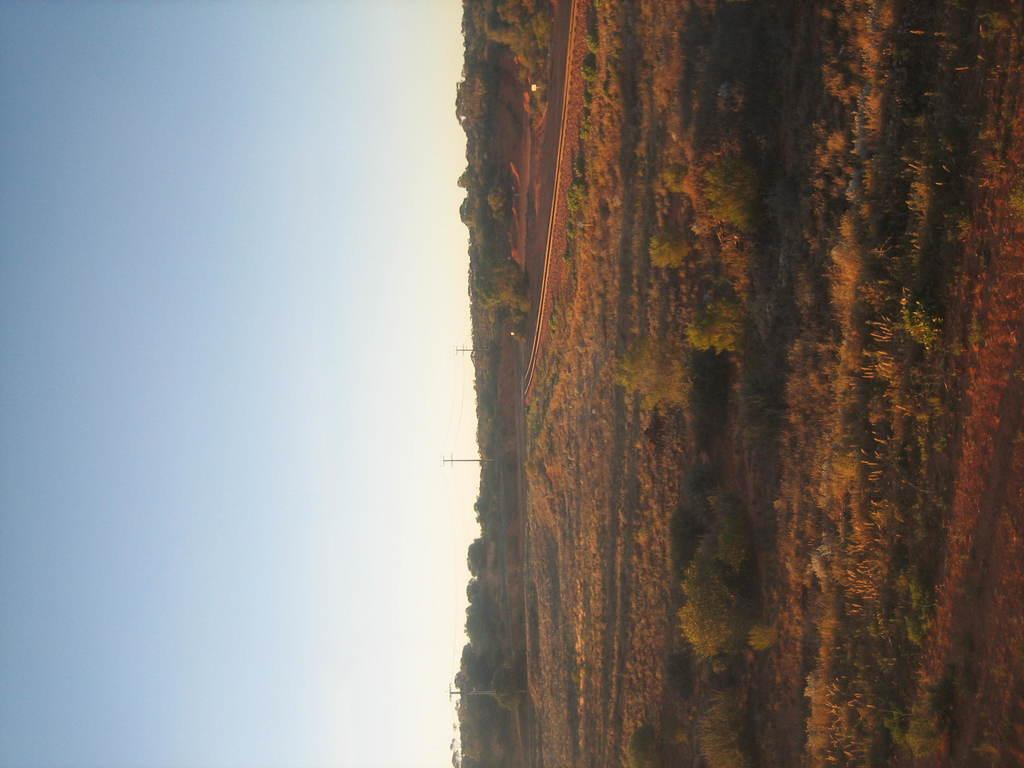What type of natural environment is depicted in the image? There is greenery in the image, suggesting a natural setting. What objects can be seen on the right side of the image? There are poles on the right side of the image. What part of the sky can be seen in the image? There is sky visible on the left side of the image. How many dinosaurs can be seen grazing in the greenery in the image? There are no dinosaurs present in the image; it depicts a natural setting with greenery and poles. What type of furniture is visible in the image? There is no furniture visible in the image, as it primarily features greenery, poles, and sky. 